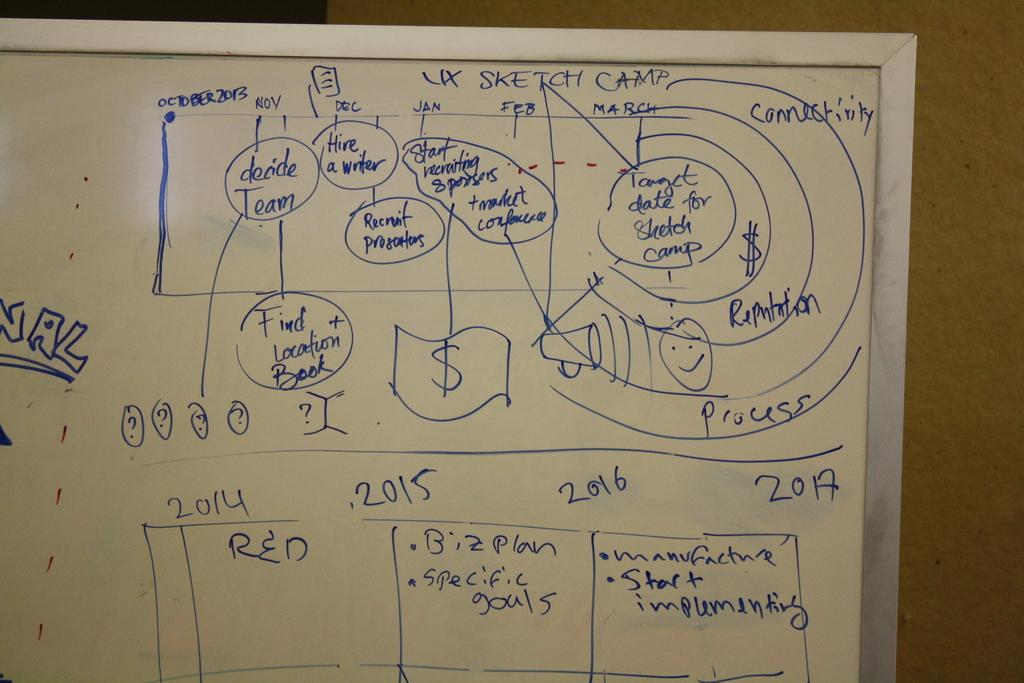Provide a one-sentence caption for the provided image. A whiteboard has information about the UX Sketch Camp drawn on it. 